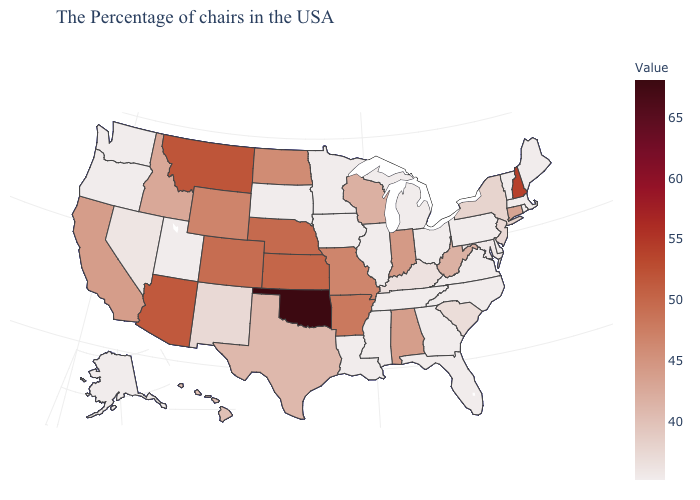Among the states that border Connecticut , does New York have the lowest value?
Quick response, please. No. Does Ohio have a lower value than Indiana?
Give a very brief answer. Yes. Does Rhode Island have the lowest value in the USA?
Give a very brief answer. Yes. Which states hav the highest value in the West?
Keep it brief. Montana. Among the states that border Arizona , which have the lowest value?
Quick response, please. Utah. Is the legend a continuous bar?
Be succinct. Yes. Among the states that border Georgia , which have the lowest value?
Short answer required. North Carolina, Florida, Tennessee. 